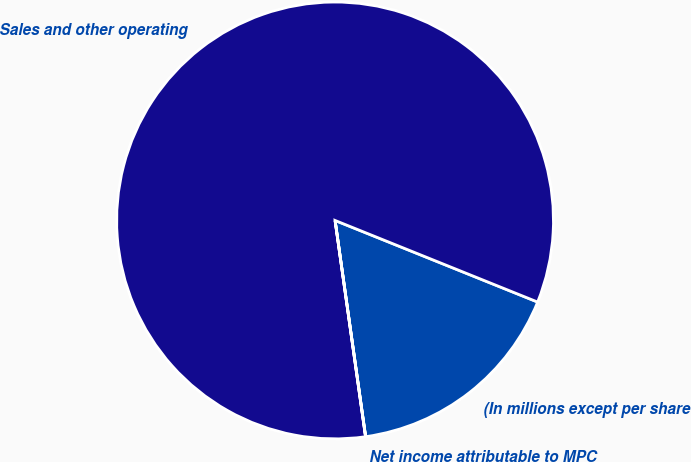<chart> <loc_0><loc_0><loc_500><loc_500><pie_chart><fcel>(In millions except per share<fcel>Sales and other operating<fcel>Net income attributable to MPC<nl><fcel>16.67%<fcel>83.33%<fcel>0.01%<nl></chart> 